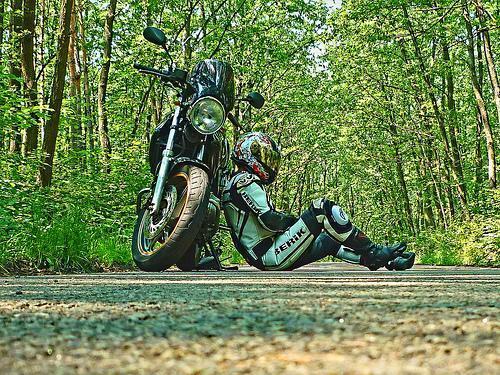How many people are there?
Give a very brief answer. 1. How many headlights does the motorcycle have?
Give a very brief answer. 1. 